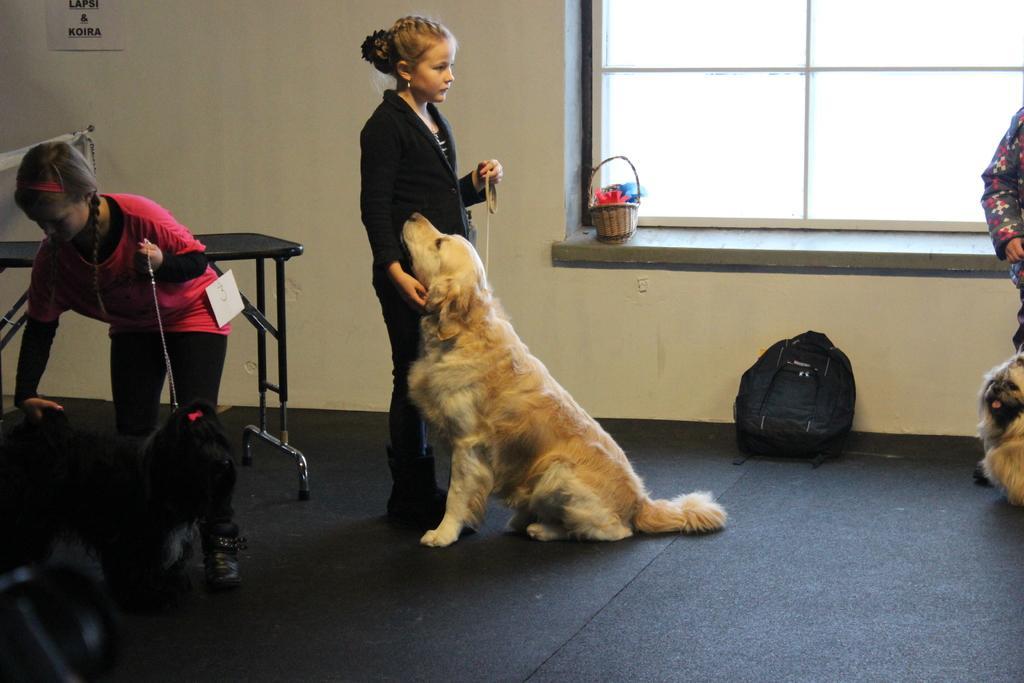Can you describe this image briefly? In this image we can see three children standing on the floor holding the dogs. We can also see a table, a bag, a paper on a wall and a basket beside a window. 